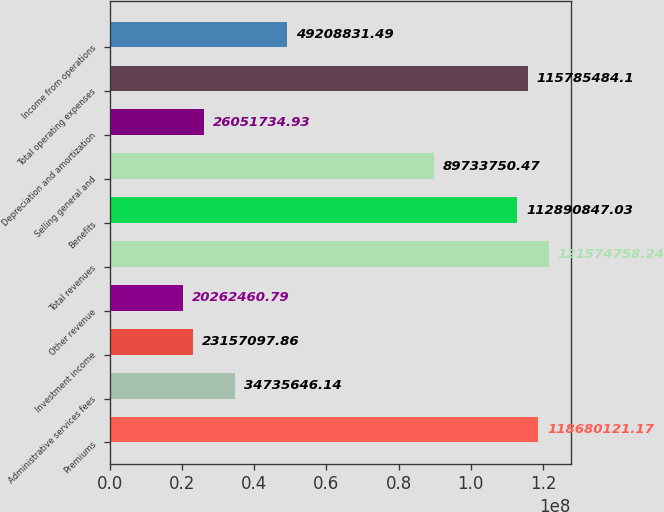Convert chart to OTSL. <chart><loc_0><loc_0><loc_500><loc_500><bar_chart><fcel>Premiums<fcel>Administrative services fees<fcel>Investment income<fcel>Other revenue<fcel>Total revenues<fcel>Benefits<fcel>Selling general and<fcel>Depreciation and amortization<fcel>Total operating expenses<fcel>Income from operations<nl><fcel>1.1868e+08<fcel>3.47356e+07<fcel>2.31571e+07<fcel>2.02625e+07<fcel>1.21575e+08<fcel>1.12891e+08<fcel>8.97338e+07<fcel>2.60517e+07<fcel>1.15785e+08<fcel>4.92088e+07<nl></chart> 